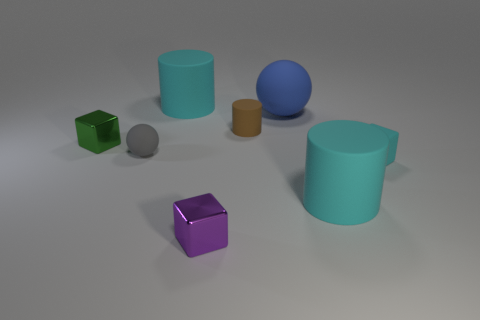How many things are either blocks or tiny gray rubber things?
Make the answer very short. 4. There is a matte sphere that is the same size as the green metallic thing; what color is it?
Provide a short and direct response. Gray. There is a large blue object; is its shape the same as the small rubber thing that is to the left of the tiny cylinder?
Your response must be concise. Yes. What number of objects are either tiny rubber objects that are behind the green block or cyan cylinders to the left of the small rubber cylinder?
Provide a short and direct response. 2. There is a large matte object that is in front of the large blue sphere; what is its shape?
Provide a succinct answer. Cylinder. There is a large rubber thing that is in front of the gray object; is its shape the same as the tiny brown matte object?
Offer a very short reply. Yes. What number of objects are either small rubber objects that are to the left of the tiny cyan object or small purple cubes?
Give a very brief answer. 3. What is the color of the tiny matte thing that is the same shape as the large blue thing?
Your answer should be very brief. Gray. Is there any other thing that has the same color as the small matte block?
Your response must be concise. Yes. What size is the ball that is in front of the small green cube?
Your answer should be very brief. Small. 